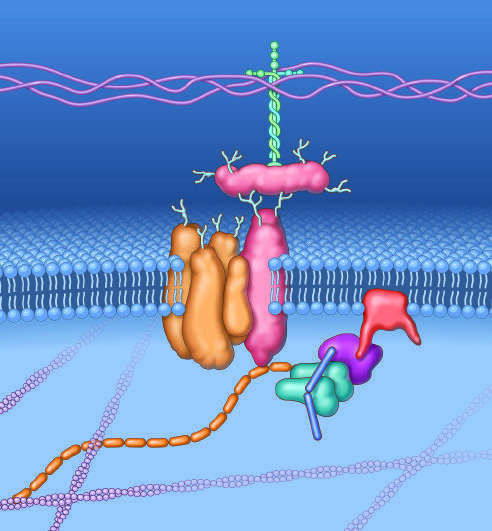re characteristic intranuclear inclusions made by dystrophin?
Answer the question using a single word or phrase. No 